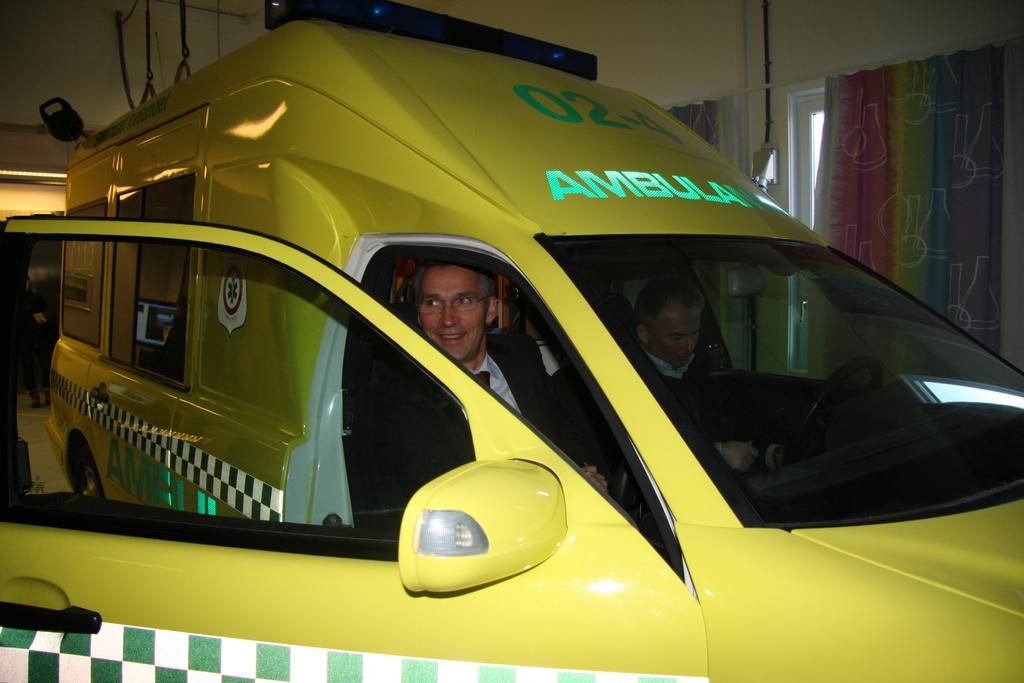<image>
Write a terse but informative summary of the picture. a yellow vehicle with the word Ambulance on top 